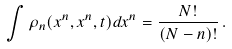Convert formula to latex. <formula><loc_0><loc_0><loc_500><loc_500>\int \rho _ { n } ( x ^ { n } , x ^ { n } , t ) d x ^ { n } = \frac { N ! } { ( N - n ) ! } \, .</formula> 